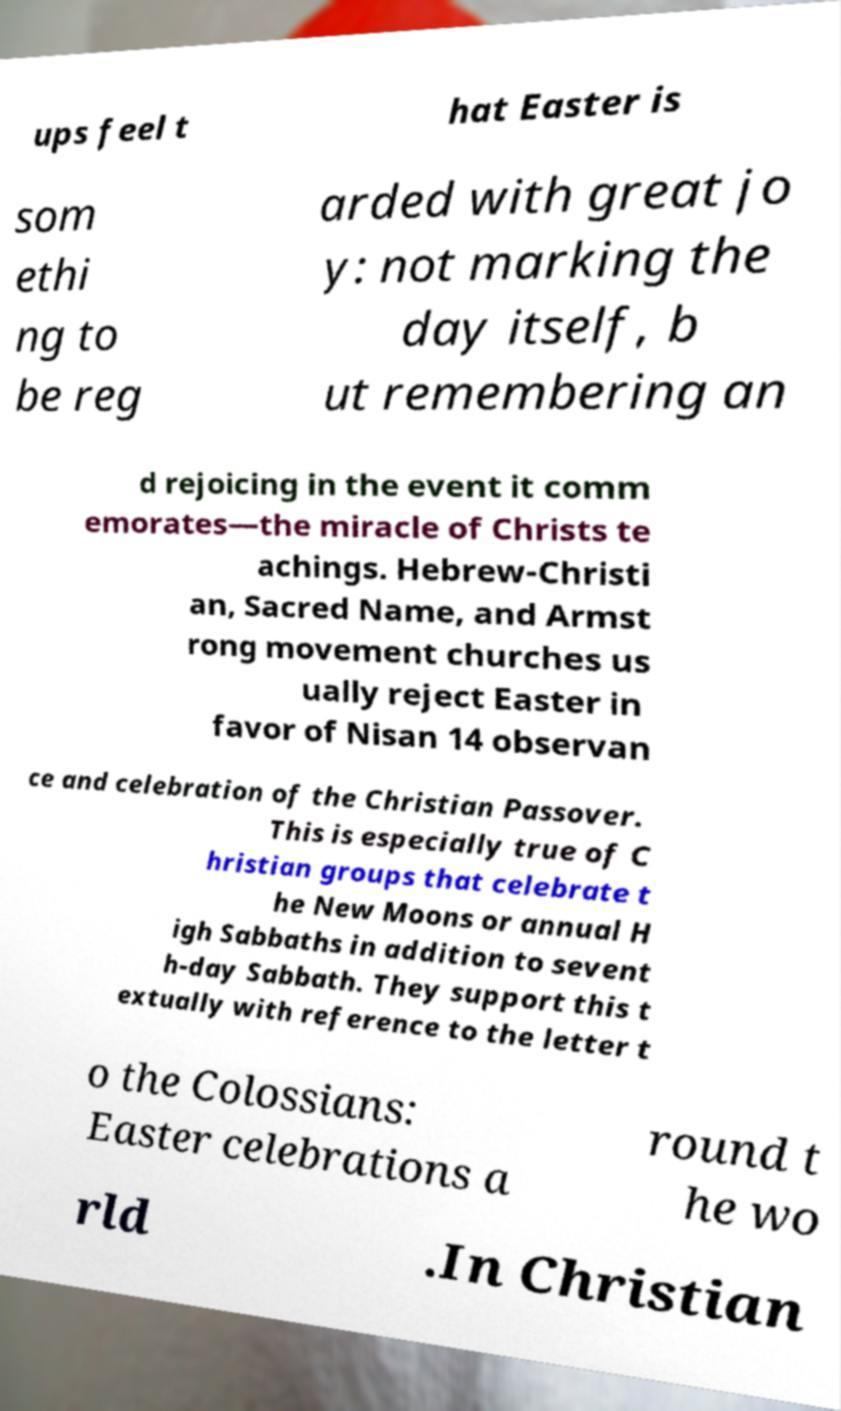Can you accurately transcribe the text from the provided image for me? ups feel t hat Easter is som ethi ng to be reg arded with great jo y: not marking the day itself, b ut remembering an d rejoicing in the event it comm emorates—the miracle of Christs te achings. Hebrew-Christi an, Sacred Name, and Armst rong movement churches us ually reject Easter in favor of Nisan 14 observan ce and celebration of the Christian Passover. This is especially true of C hristian groups that celebrate t he New Moons or annual H igh Sabbaths in addition to sevent h-day Sabbath. They support this t extually with reference to the letter t o the Colossians: Easter celebrations a round t he wo rld .In Christian 